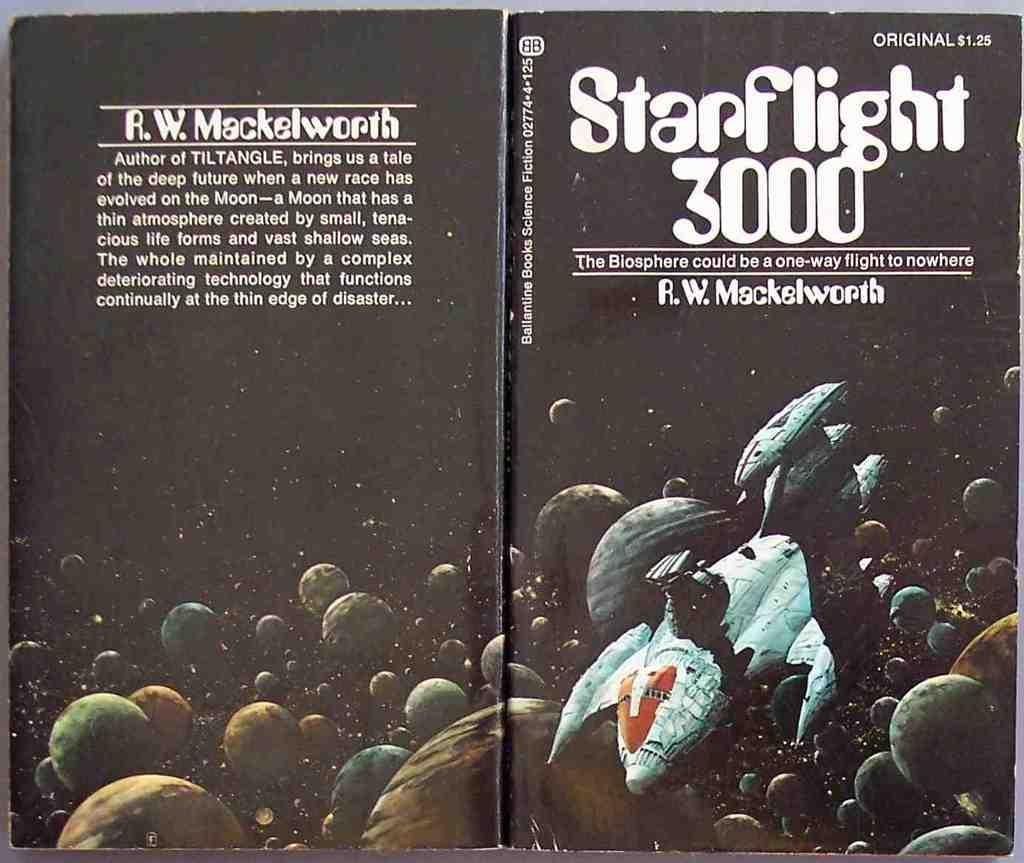<image>
Offer a succinct explanation of the picture presented. An open book called Starflight 3000 with a spaceship flying by planets on it. 